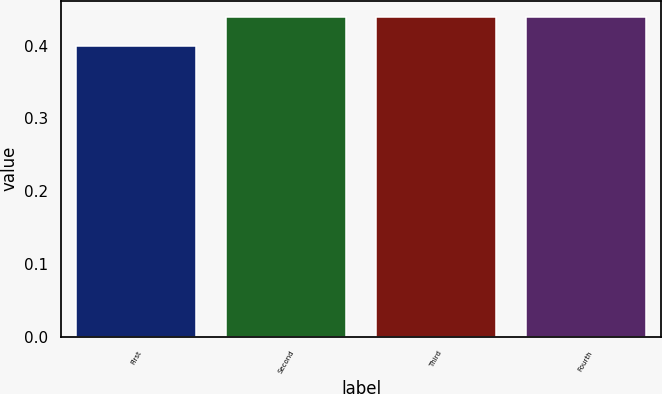Convert chart. <chart><loc_0><loc_0><loc_500><loc_500><bar_chart><fcel>First<fcel>Second<fcel>Third<fcel>Fourth<nl><fcel>0.4<fcel>0.44<fcel>0.44<fcel>0.44<nl></chart> 